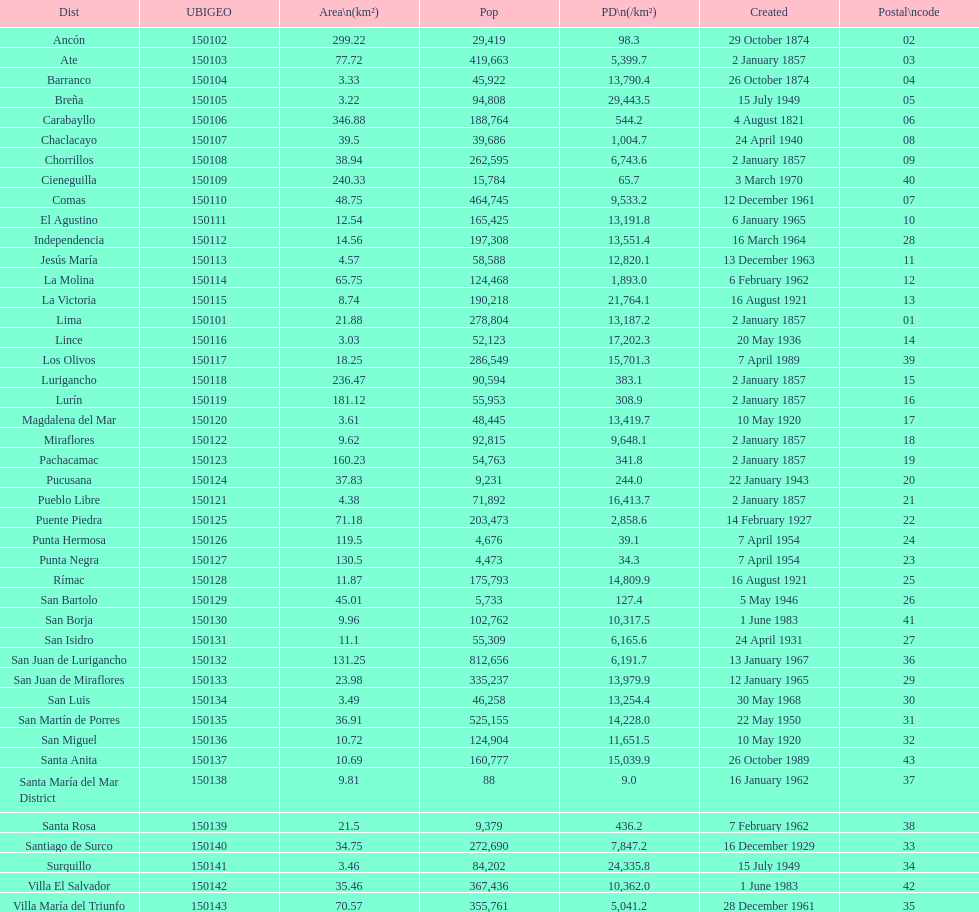Parse the full table. {'header': ['Dist', 'UBIGEO', 'Area\\n(km²)', 'Pop', 'PD\\n(/km²)', 'Created', 'Postal\\ncode'], 'rows': [['Ancón', '150102', '299.22', '29,419', '98.3', '29 October 1874', '02'], ['Ate', '150103', '77.72', '419,663', '5,399.7', '2 January 1857', '03'], ['Barranco', '150104', '3.33', '45,922', '13,790.4', '26 October 1874', '04'], ['Breña', '150105', '3.22', '94,808', '29,443.5', '15 July 1949', '05'], ['Carabayllo', '150106', '346.88', '188,764', '544.2', '4 August 1821', '06'], ['Chaclacayo', '150107', '39.5', '39,686', '1,004.7', '24 April 1940', '08'], ['Chorrillos', '150108', '38.94', '262,595', '6,743.6', '2 January 1857', '09'], ['Cieneguilla', '150109', '240.33', '15,784', '65.7', '3 March 1970', '40'], ['Comas', '150110', '48.75', '464,745', '9,533.2', '12 December 1961', '07'], ['El Agustino', '150111', '12.54', '165,425', '13,191.8', '6 January 1965', '10'], ['Independencia', '150112', '14.56', '197,308', '13,551.4', '16 March 1964', '28'], ['Jesús María', '150113', '4.57', '58,588', '12,820.1', '13 December 1963', '11'], ['La Molina', '150114', '65.75', '124,468', '1,893.0', '6 February 1962', '12'], ['La Victoria', '150115', '8.74', '190,218', '21,764.1', '16 August 1921', '13'], ['Lima', '150101', '21.88', '278,804', '13,187.2', '2 January 1857', '01'], ['Lince', '150116', '3.03', '52,123', '17,202.3', '20 May 1936', '14'], ['Los Olivos', '150117', '18.25', '286,549', '15,701.3', '7 April 1989', '39'], ['Lurigancho', '150118', '236.47', '90,594', '383.1', '2 January 1857', '15'], ['Lurín', '150119', '181.12', '55,953', '308.9', '2 January 1857', '16'], ['Magdalena del Mar', '150120', '3.61', '48,445', '13,419.7', '10 May 1920', '17'], ['Miraflores', '150122', '9.62', '92,815', '9,648.1', '2 January 1857', '18'], ['Pachacamac', '150123', '160.23', '54,763', '341.8', '2 January 1857', '19'], ['Pucusana', '150124', '37.83', '9,231', '244.0', '22 January 1943', '20'], ['Pueblo Libre', '150121', '4.38', '71,892', '16,413.7', '2 January 1857', '21'], ['Puente Piedra', '150125', '71.18', '203,473', '2,858.6', '14 February 1927', '22'], ['Punta Hermosa', '150126', '119.5', '4,676', '39.1', '7 April 1954', '24'], ['Punta Negra', '150127', '130.5', '4,473', '34.3', '7 April 1954', '23'], ['Rímac', '150128', '11.87', '175,793', '14,809.9', '16 August 1921', '25'], ['San Bartolo', '150129', '45.01', '5,733', '127.4', '5 May 1946', '26'], ['San Borja', '150130', '9.96', '102,762', '10,317.5', '1 June 1983', '41'], ['San Isidro', '150131', '11.1', '55,309', '6,165.6', '24 April 1931', '27'], ['San Juan de Lurigancho', '150132', '131.25', '812,656', '6,191.7', '13 January 1967', '36'], ['San Juan de Miraflores', '150133', '23.98', '335,237', '13,979.9', '12 January 1965', '29'], ['San Luis', '150134', '3.49', '46,258', '13,254.4', '30 May 1968', '30'], ['San Martín de Porres', '150135', '36.91', '525,155', '14,228.0', '22 May 1950', '31'], ['San Miguel', '150136', '10.72', '124,904', '11,651.5', '10 May 1920', '32'], ['Santa Anita', '150137', '10.69', '160,777', '15,039.9', '26 October 1989', '43'], ['Santa María del Mar District', '150138', '9.81', '88', '9.0', '16 January 1962', '37'], ['Santa Rosa', '150139', '21.5', '9,379', '436.2', '7 February 1962', '38'], ['Santiago de Surco', '150140', '34.75', '272,690', '7,847.2', '16 December 1929', '33'], ['Surquillo', '150141', '3.46', '84,202', '24,335.8', '15 July 1949', '34'], ['Villa El Salvador', '150142', '35.46', '367,436', '10,362.0', '1 June 1983', '42'], ['Villa María del Triunfo', '150143', '70.57', '355,761', '5,041.2', '28 December 1961', '35']]} What was the most recent district established? Santa Anita. 